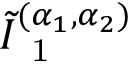Convert formula to latex. <formula><loc_0><loc_0><loc_500><loc_500>\tilde { I } _ { 1 } ^ { ( \alpha _ { 1 } , \alpha _ { 2 } ) }</formula> 